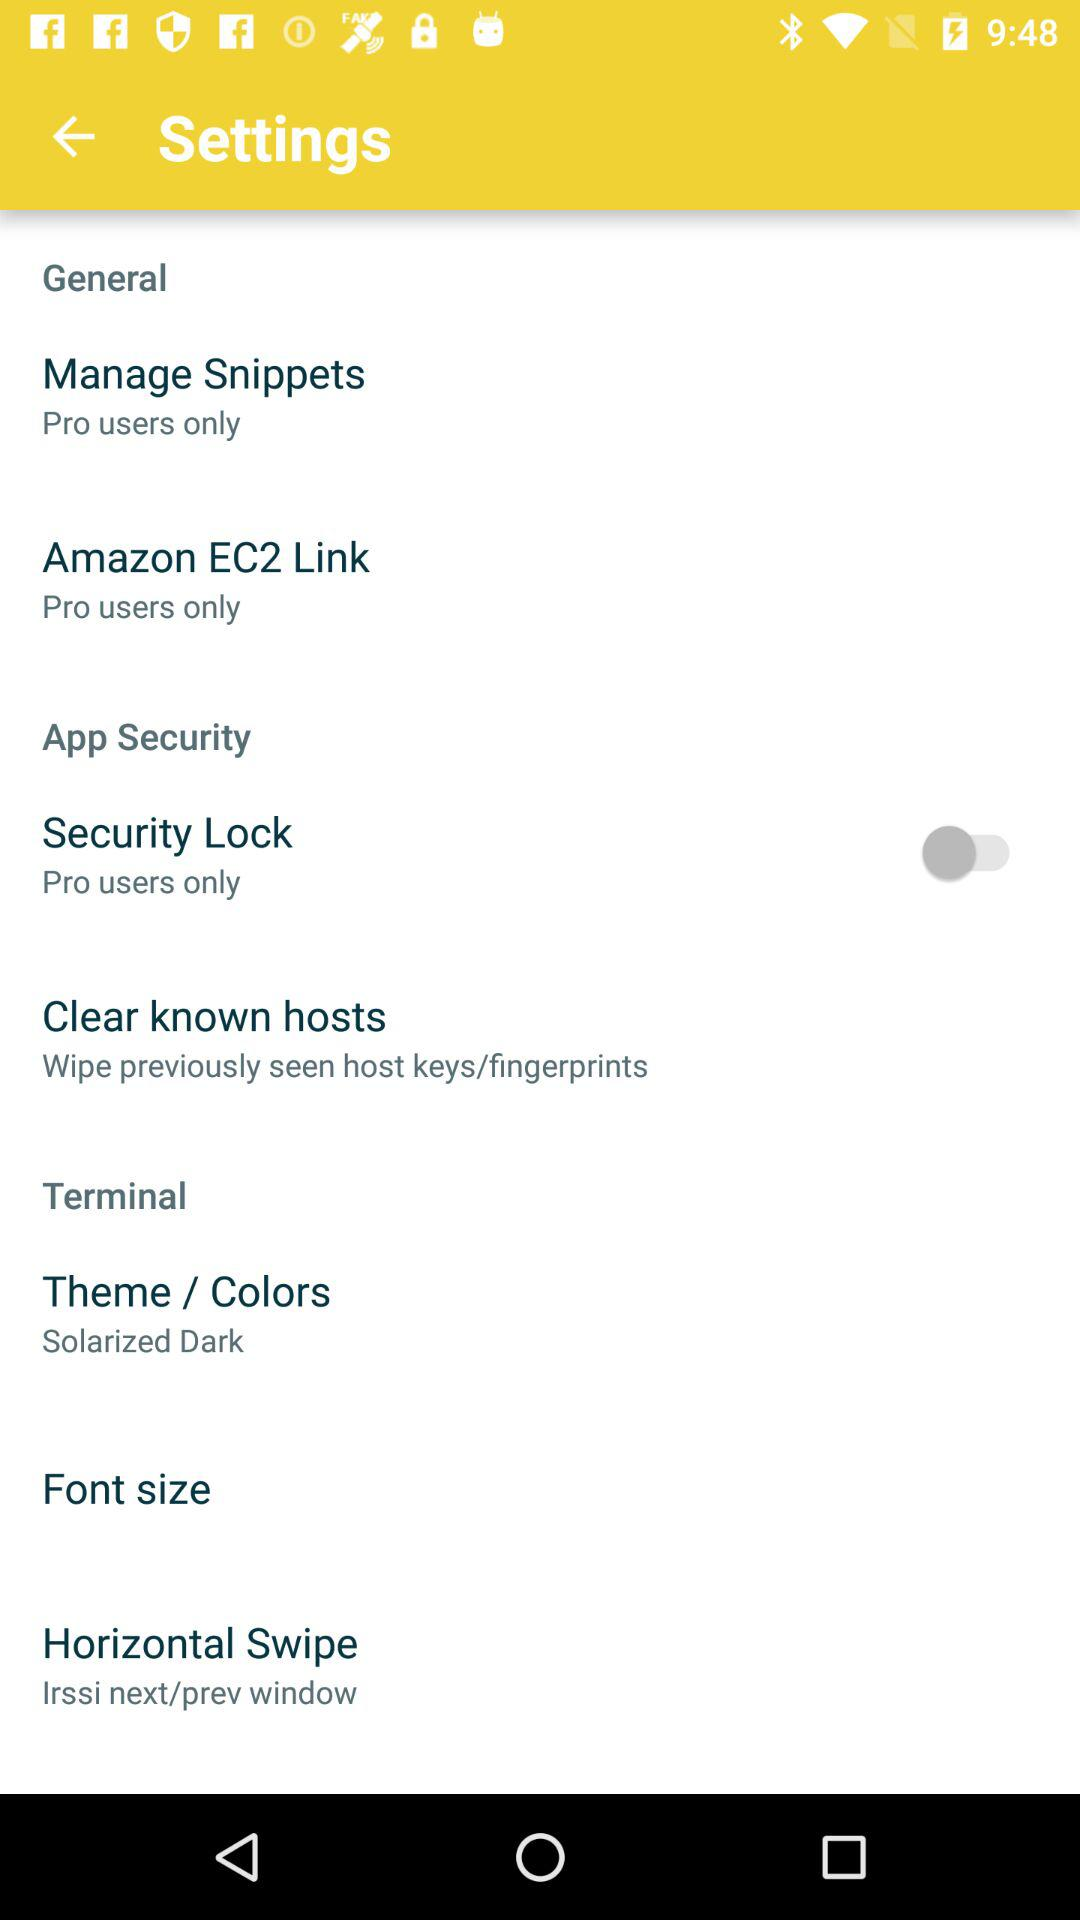What is the status of the security lock? The status is off. 